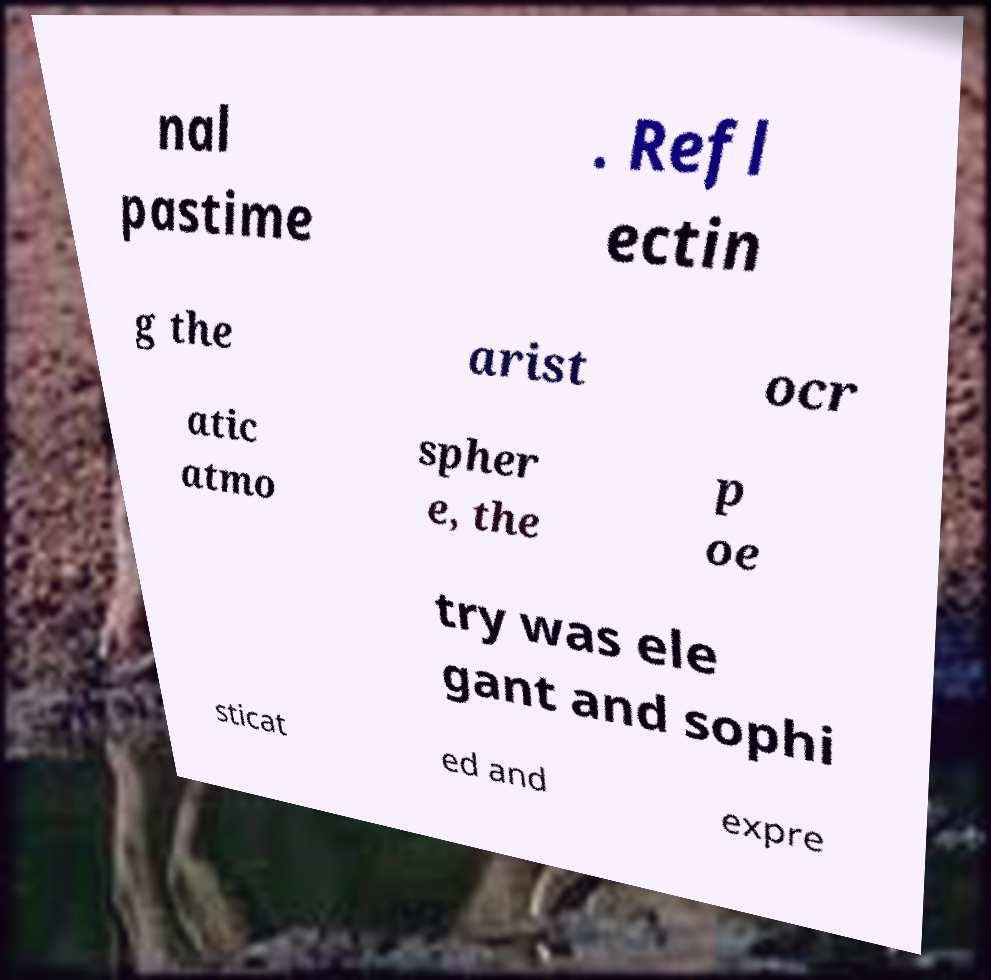Can you read and provide the text displayed in the image?This photo seems to have some interesting text. Can you extract and type it out for me? nal pastime . Refl ectin g the arist ocr atic atmo spher e, the p oe try was ele gant and sophi sticat ed and expre 